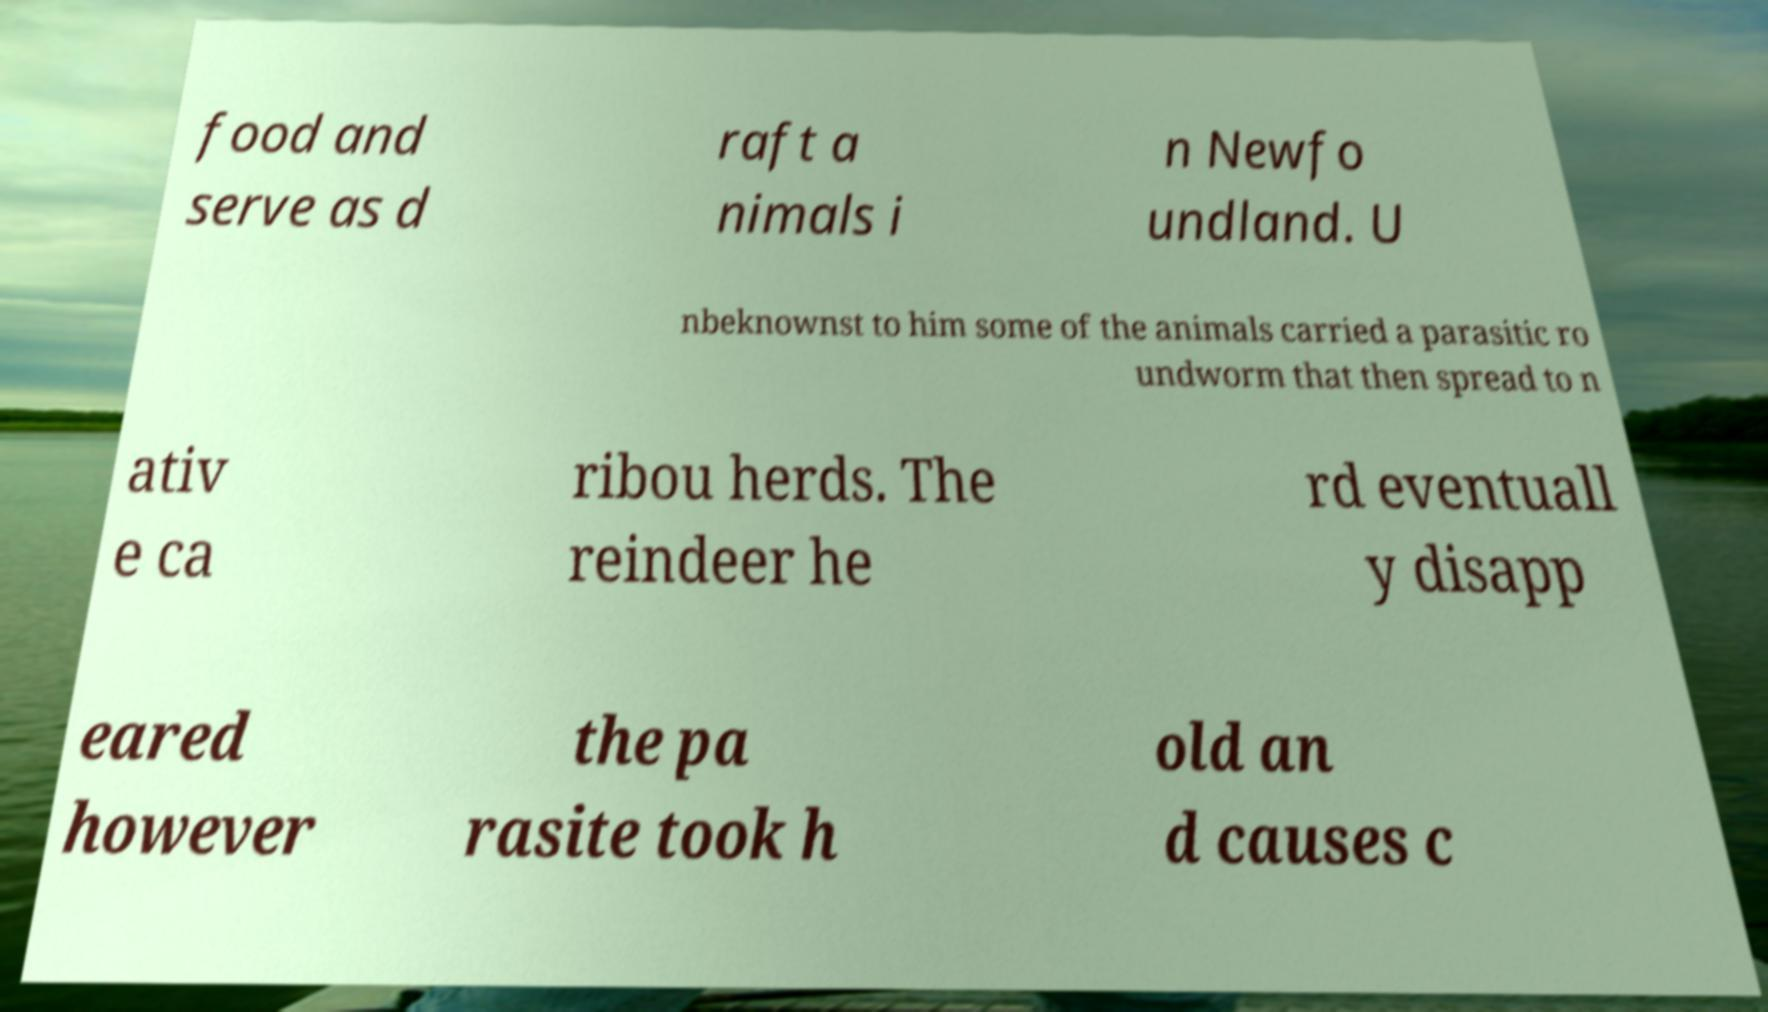I need the written content from this picture converted into text. Can you do that? food and serve as d raft a nimals i n Newfo undland. U nbeknownst to him some of the animals carried a parasitic ro undworm that then spread to n ativ e ca ribou herds. The reindeer he rd eventuall y disapp eared however the pa rasite took h old an d causes c 